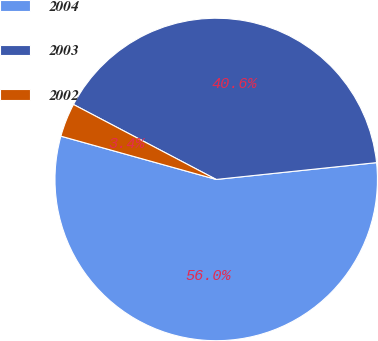Convert chart. <chart><loc_0><loc_0><loc_500><loc_500><pie_chart><fcel>2004<fcel>2003<fcel>2002<nl><fcel>55.99%<fcel>40.64%<fcel>3.37%<nl></chart> 